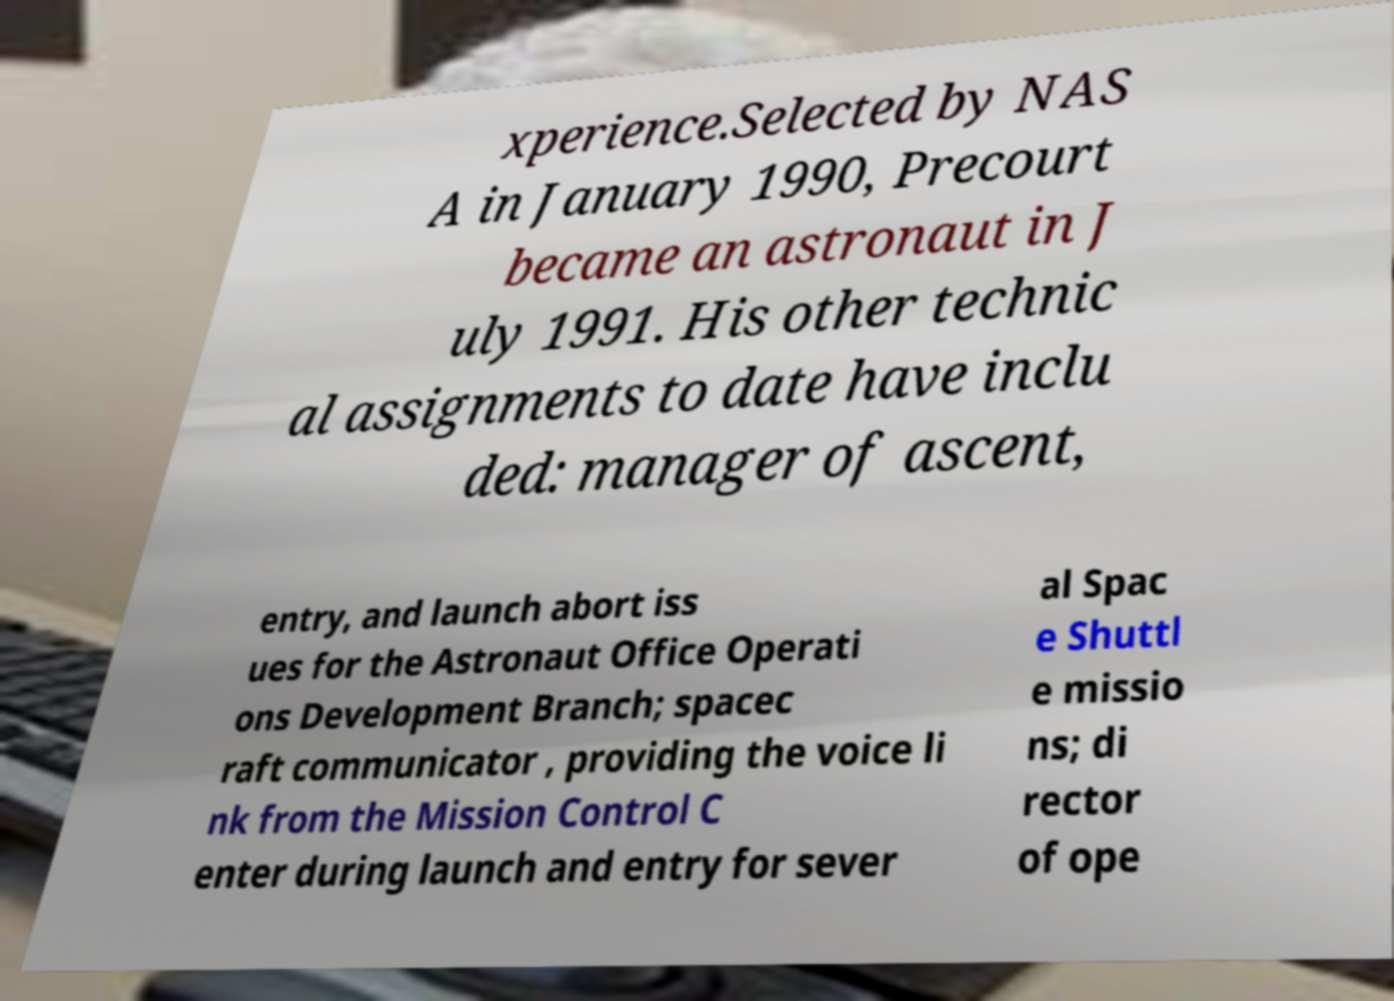Can you read and provide the text displayed in the image?This photo seems to have some interesting text. Can you extract and type it out for me? xperience.Selected by NAS A in January 1990, Precourt became an astronaut in J uly 1991. His other technic al assignments to date have inclu ded: manager of ascent, entry, and launch abort iss ues for the Astronaut Office Operati ons Development Branch; spacec raft communicator , providing the voice li nk from the Mission Control C enter during launch and entry for sever al Spac e Shuttl e missio ns; di rector of ope 